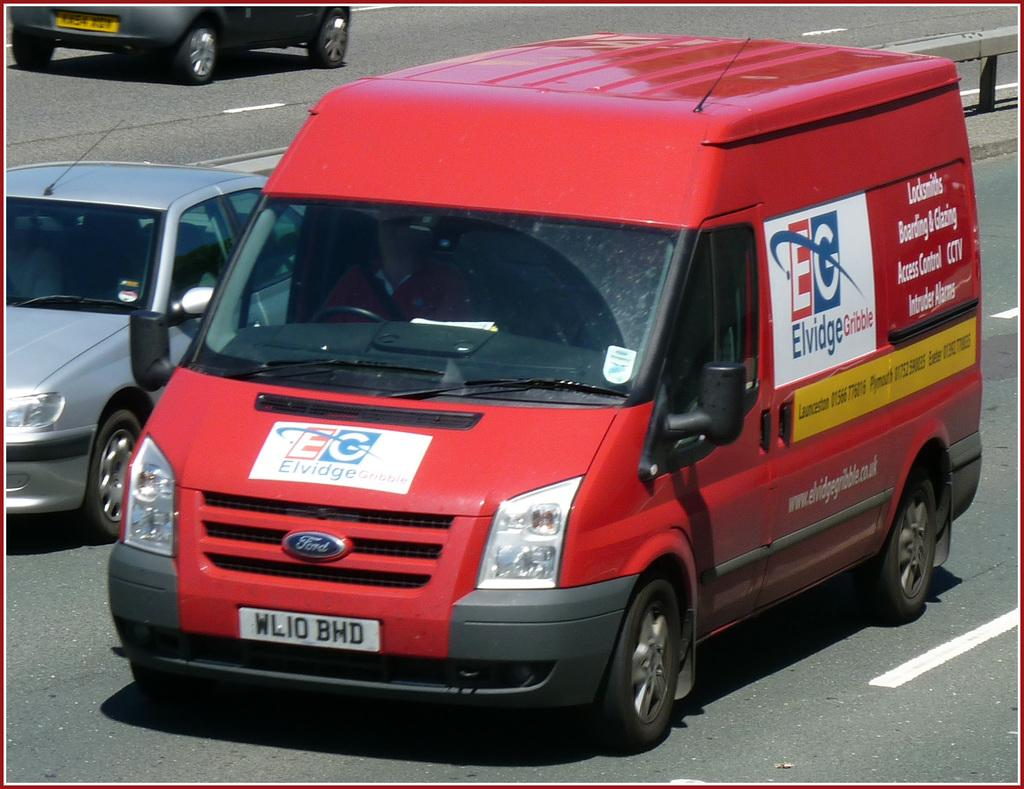<image>
Provide a brief description of the given image. A red Ford vehicle for Elvidge Gribble is driving on the street. 